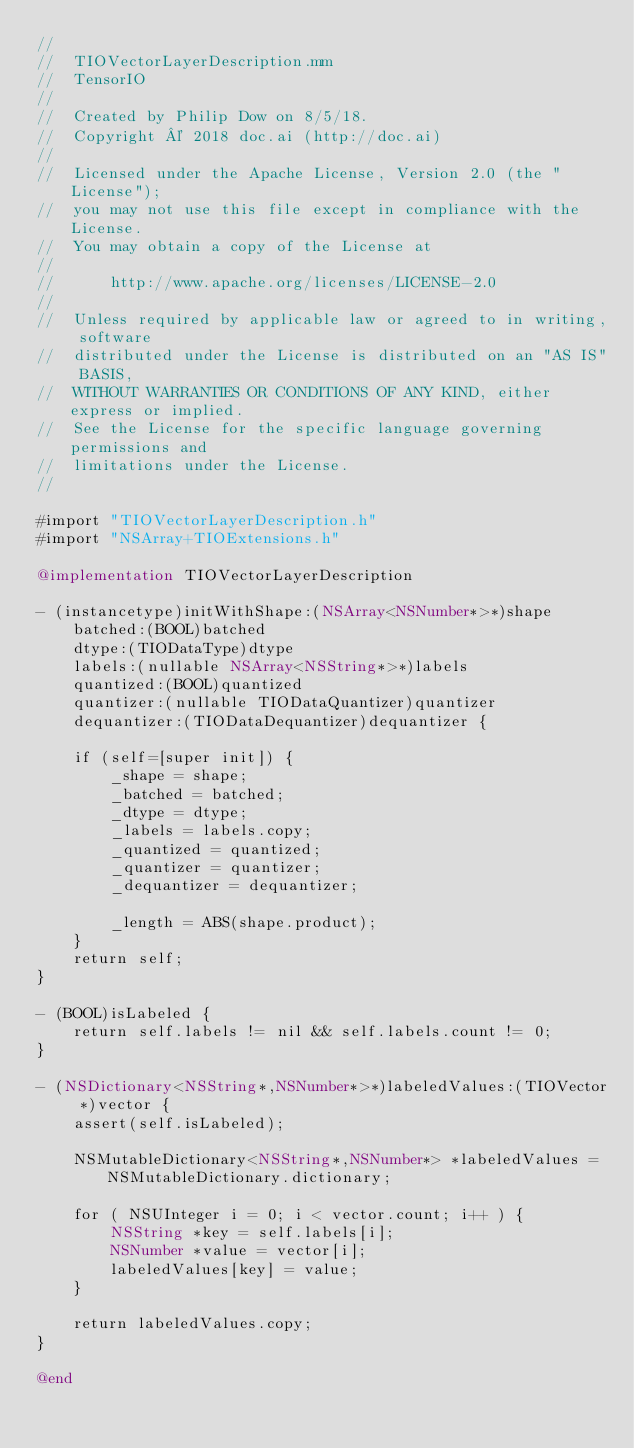Convert code to text. <code><loc_0><loc_0><loc_500><loc_500><_ObjectiveC_>//
//  TIOVectorLayerDescription.mm
//  TensorIO
//
//  Created by Philip Dow on 8/5/18.
//  Copyright © 2018 doc.ai (http://doc.ai)
//
//  Licensed under the Apache License, Version 2.0 (the "License");
//  you may not use this file except in compliance with the License.
//  You may obtain a copy of the License at
//
//      http://www.apache.org/licenses/LICENSE-2.0
//
//  Unless required by applicable law or agreed to in writing, software
//  distributed under the License is distributed on an "AS IS" BASIS,
//  WITHOUT WARRANTIES OR CONDITIONS OF ANY KIND, either express or implied.
//  See the License for the specific language governing permissions and
//  limitations under the License.
//

#import "TIOVectorLayerDescription.h"
#import "NSArray+TIOExtensions.h"

@implementation TIOVectorLayerDescription

- (instancetype)initWithShape:(NSArray<NSNumber*>*)shape
    batched:(BOOL)batched
    dtype:(TIODataType)dtype
    labels:(nullable NSArray<NSString*>*)labels
    quantized:(BOOL)quantized
    quantizer:(nullable TIODataQuantizer)quantizer
    dequantizer:(TIODataDequantizer)dequantizer {
    
    if (self=[super init]) {
        _shape = shape;
        _batched = batched;
        _dtype = dtype;
        _labels = labels.copy;
        _quantized = quantized;
        _quantizer = quantizer;
        _dequantizer = dequantizer;
        
        _length = ABS(shape.product);
    }
    return self;
}

- (BOOL)isLabeled {
    return self.labels != nil && self.labels.count != 0;
}

- (NSDictionary<NSString*,NSNumber*>*)labeledValues:(TIOVector *)vector {
    assert(self.isLabeled);
    
    NSMutableDictionary<NSString*,NSNumber*> *labeledValues = NSMutableDictionary.dictionary;
    
    for ( NSUInteger i = 0; i < vector.count; i++ ) {
        NSString *key = self.labels[i];
        NSNumber *value = vector[i];
        labeledValues[key] = value;
    }
    
    return labeledValues.copy;
}

@end
</code> 